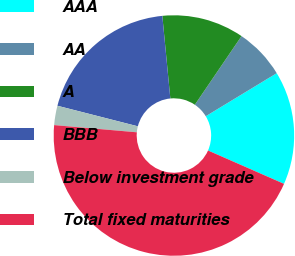<chart> <loc_0><loc_0><loc_500><loc_500><pie_chart><fcel>AAA<fcel>AA<fcel>A<fcel>BBB<fcel>Below investment grade<fcel>Total fixed maturities<nl><fcel>15.26%<fcel>6.82%<fcel>11.04%<fcel>19.48%<fcel>2.6%<fcel>44.8%<nl></chart> 